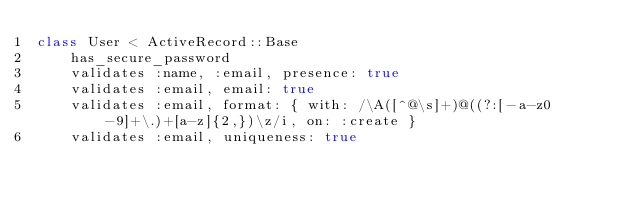<code> <loc_0><loc_0><loc_500><loc_500><_Ruby_>class User < ActiveRecord::Base
    has_secure_password
    validates :name, :email, presence: true 
    validates :email, email: true
    validates :email, format: { with: /\A([^@\s]+)@((?:[-a-z0-9]+\.)+[a-z]{2,})\z/i, on: :create }
    validates :email, uniqueness: true</code> 